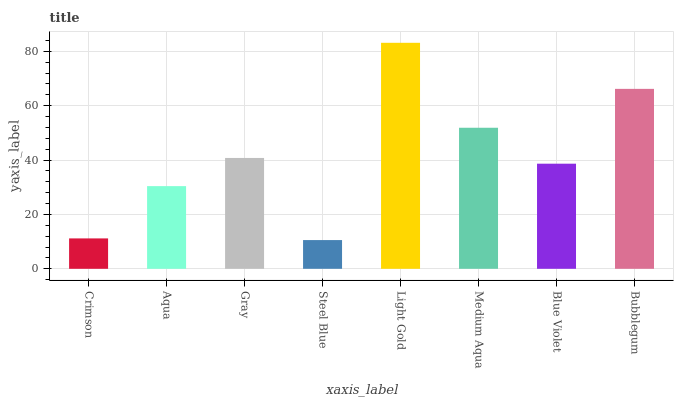Is Steel Blue the minimum?
Answer yes or no. Yes. Is Light Gold the maximum?
Answer yes or no. Yes. Is Aqua the minimum?
Answer yes or no. No. Is Aqua the maximum?
Answer yes or no. No. Is Aqua greater than Crimson?
Answer yes or no. Yes. Is Crimson less than Aqua?
Answer yes or no. Yes. Is Crimson greater than Aqua?
Answer yes or no. No. Is Aqua less than Crimson?
Answer yes or no. No. Is Gray the high median?
Answer yes or no. Yes. Is Blue Violet the low median?
Answer yes or no. Yes. Is Crimson the high median?
Answer yes or no. No. Is Crimson the low median?
Answer yes or no. No. 